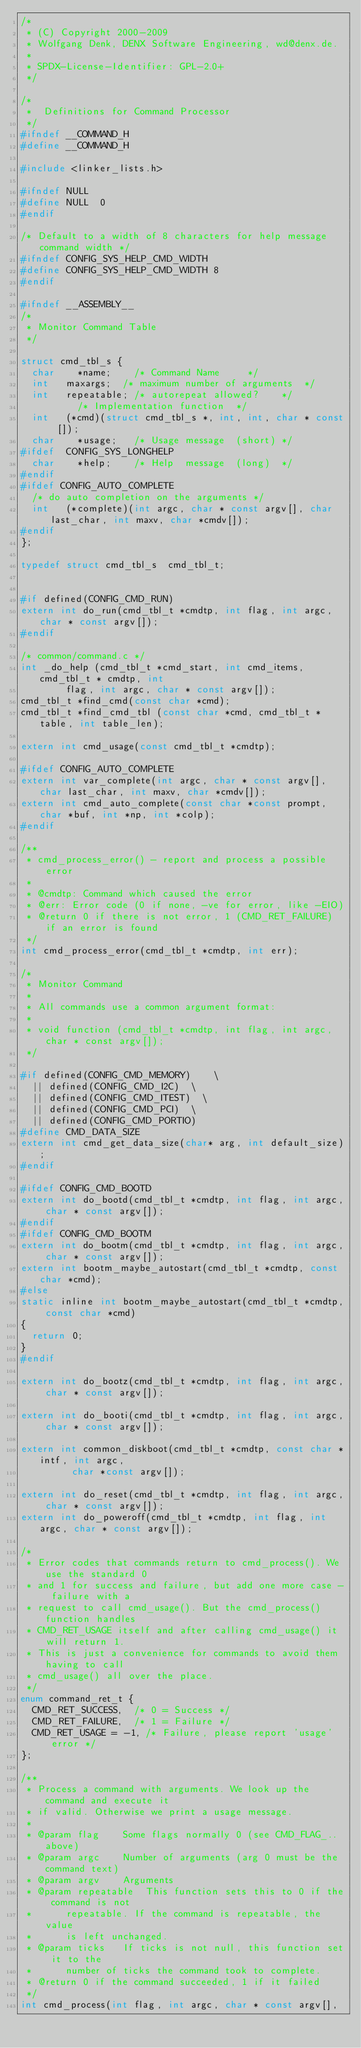<code> <loc_0><loc_0><loc_500><loc_500><_C_>/*
 * (C) Copyright 2000-2009
 * Wolfgang Denk, DENX Software Engineering, wd@denx.de.
 *
 * SPDX-License-Identifier:	GPL-2.0+
 */

/*
 *  Definitions for Command Processor
 */
#ifndef __COMMAND_H
#define __COMMAND_H

#include <linker_lists.h>

#ifndef NULL
#define NULL	0
#endif

/* Default to a width of 8 characters for help message command width */
#ifndef CONFIG_SYS_HELP_CMD_WIDTH
#define CONFIG_SYS_HELP_CMD_WIDTH	8
#endif

#ifndef	__ASSEMBLY__
/*
 * Monitor Command Table
 */

struct cmd_tbl_s {
	char		*name;		/* Command Name			*/
	int		maxargs;	/* maximum number of arguments	*/
	int		repeatable;	/* autorepeat allowed?		*/
					/* Implementation function	*/
	int		(*cmd)(struct cmd_tbl_s *, int, int, char * const []);
	char		*usage;		/* Usage message	(short)	*/
#ifdef	CONFIG_SYS_LONGHELP
	char		*help;		/* Help  message	(long)	*/
#endif
#ifdef CONFIG_AUTO_COMPLETE
	/* do auto completion on the arguments */
	int		(*complete)(int argc, char * const argv[], char last_char, int maxv, char *cmdv[]);
#endif
};

typedef struct cmd_tbl_s	cmd_tbl_t;


#if defined(CONFIG_CMD_RUN)
extern int do_run(cmd_tbl_t *cmdtp, int flag, int argc, char * const argv[]);
#endif

/* common/command.c */
int _do_help (cmd_tbl_t *cmd_start, int cmd_items, cmd_tbl_t * cmdtp, int
	      flag, int argc, char * const argv[]);
cmd_tbl_t *find_cmd(const char *cmd);
cmd_tbl_t *find_cmd_tbl (const char *cmd, cmd_tbl_t *table, int table_len);

extern int cmd_usage(const cmd_tbl_t *cmdtp);

#ifdef CONFIG_AUTO_COMPLETE
extern int var_complete(int argc, char * const argv[], char last_char, int maxv, char *cmdv[]);
extern int cmd_auto_complete(const char *const prompt, char *buf, int *np, int *colp);
#endif

/**
 * cmd_process_error() - report and process a possible error
 *
 * @cmdtp: Command which caused the error
 * @err: Error code (0 if none, -ve for error, like -EIO)
 * @return 0 if there is not error, 1 (CMD_RET_FAILURE) if an error is found
 */
int cmd_process_error(cmd_tbl_t *cmdtp, int err);

/*
 * Monitor Command
 *
 * All commands use a common argument format:
 *
 * void function (cmd_tbl_t *cmdtp, int flag, int argc, char * const argv[]);
 */

#if defined(CONFIG_CMD_MEMORY)		\
	|| defined(CONFIG_CMD_I2C)	\
	|| defined(CONFIG_CMD_ITEST)	\
	|| defined(CONFIG_CMD_PCI)	\
	|| defined(CONFIG_CMD_PORTIO)
#define CMD_DATA_SIZE
extern int cmd_get_data_size(char* arg, int default_size);
#endif

#ifdef CONFIG_CMD_BOOTD
extern int do_bootd(cmd_tbl_t *cmdtp, int flag, int argc, char * const argv[]);
#endif
#ifdef CONFIG_CMD_BOOTM
extern int do_bootm(cmd_tbl_t *cmdtp, int flag, int argc, char * const argv[]);
extern int bootm_maybe_autostart(cmd_tbl_t *cmdtp, const char *cmd);
#else
static inline int bootm_maybe_autostart(cmd_tbl_t *cmdtp, const char *cmd)
{
	return 0;
}
#endif

extern int do_bootz(cmd_tbl_t *cmdtp, int flag, int argc, char * const argv[]);

extern int do_booti(cmd_tbl_t *cmdtp, int flag, int argc, char * const argv[]);

extern int common_diskboot(cmd_tbl_t *cmdtp, const char *intf, int argc,
			   char *const argv[]);

extern int do_reset(cmd_tbl_t *cmdtp, int flag, int argc, char * const argv[]);
extern int do_poweroff(cmd_tbl_t *cmdtp, int flag, int argc, char * const argv[]);

/*
 * Error codes that commands return to cmd_process(). We use the standard 0
 * and 1 for success and failure, but add one more case - failure with a
 * request to call cmd_usage(). But the cmd_process() function handles
 * CMD_RET_USAGE itself and after calling cmd_usage() it will return 1.
 * This is just a convenience for commands to avoid them having to call
 * cmd_usage() all over the place.
 */
enum command_ret_t {
	CMD_RET_SUCCESS,	/* 0 = Success */
	CMD_RET_FAILURE,	/* 1 = Failure */
	CMD_RET_USAGE = -1,	/* Failure, please report 'usage' error */
};

/**
 * Process a command with arguments. We look up the command and execute it
 * if valid. Otherwise we print a usage message.
 *
 * @param flag		Some flags normally 0 (see CMD_FLAG_.. above)
 * @param argc		Number of arguments (arg 0 must be the command text)
 * @param argv		Arguments
 * @param repeatable	This function sets this to 0 if the command is not
 *			repeatable. If the command is repeatable, the value
 *			is left unchanged.
 * @param ticks		If ticks is not null, this function set it to the
 *			number of ticks the command took to complete.
 * @return 0 if the command succeeded, 1 if it failed
 */
int cmd_process(int flag, int argc, char * const argv[],</code> 